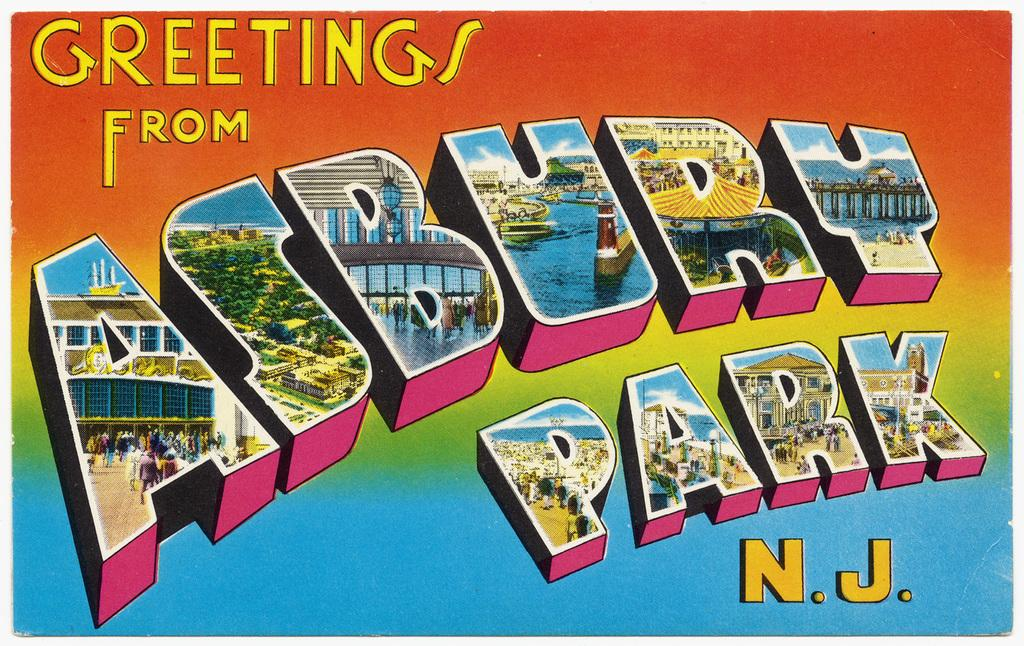What is the main object in the image? There is a card in the image. What can be found on the card? There is text written on the card. What type of pickle is mentioned in the text on the card? There is no mention of a pickle in the text on the card, as the facts only mention the presence of a card and text. 